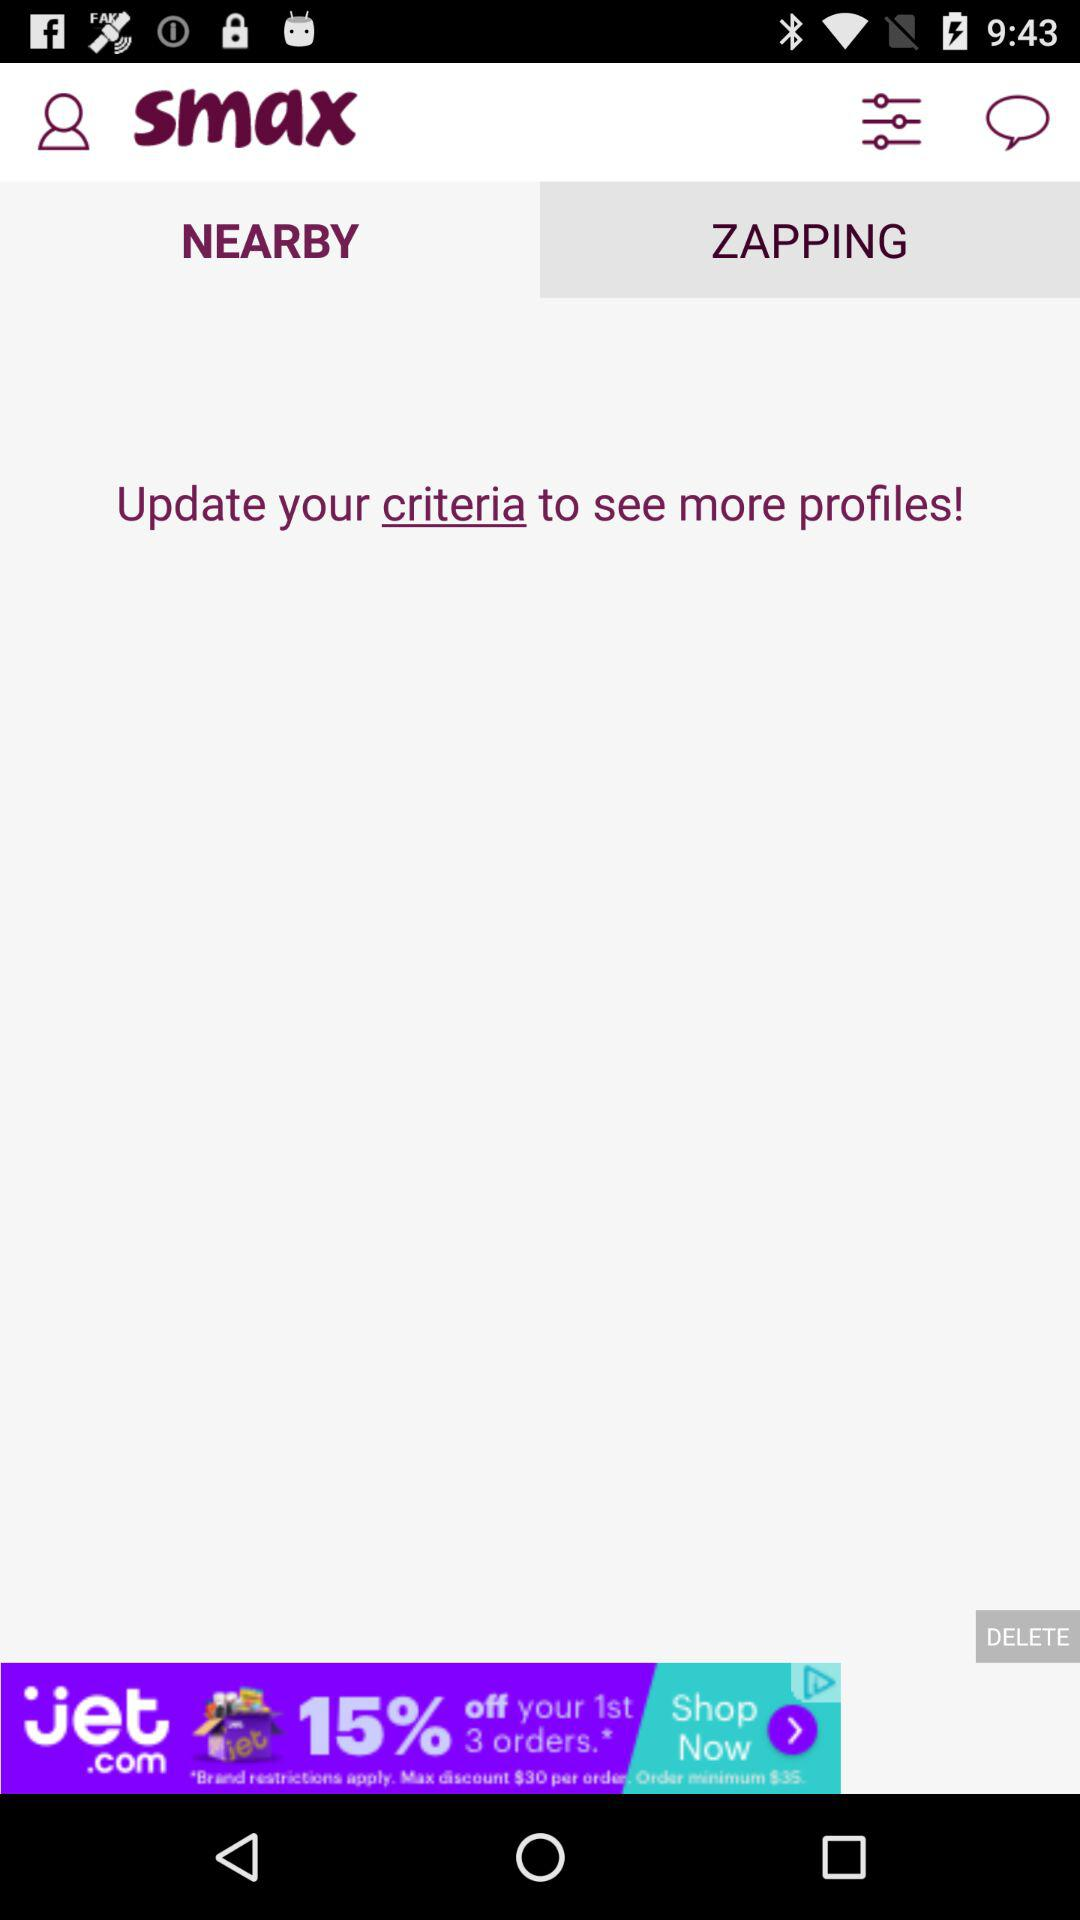What is the name of the application? The application name is "smax". 